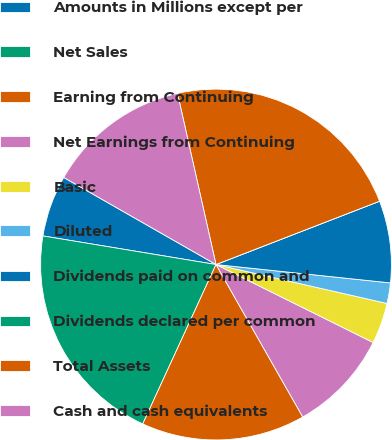Convert chart to OTSL. <chart><loc_0><loc_0><loc_500><loc_500><pie_chart><fcel>Amounts in Millions except per<fcel>Net Sales<fcel>Earning from Continuing<fcel>Net Earnings from Continuing<fcel>Basic<fcel>Diluted<fcel>Dividends paid on common and<fcel>Dividends declared per common<fcel>Total Assets<fcel>Cash and cash equivalents<nl><fcel>5.66%<fcel>20.75%<fcel>15.09%<fcel>9.43%<fcel>3.77%<fcel>1.89%<fcel>7.55%<fcel>0.0%<fcel>22.64%<fcel>13.21%<nl></chart> 